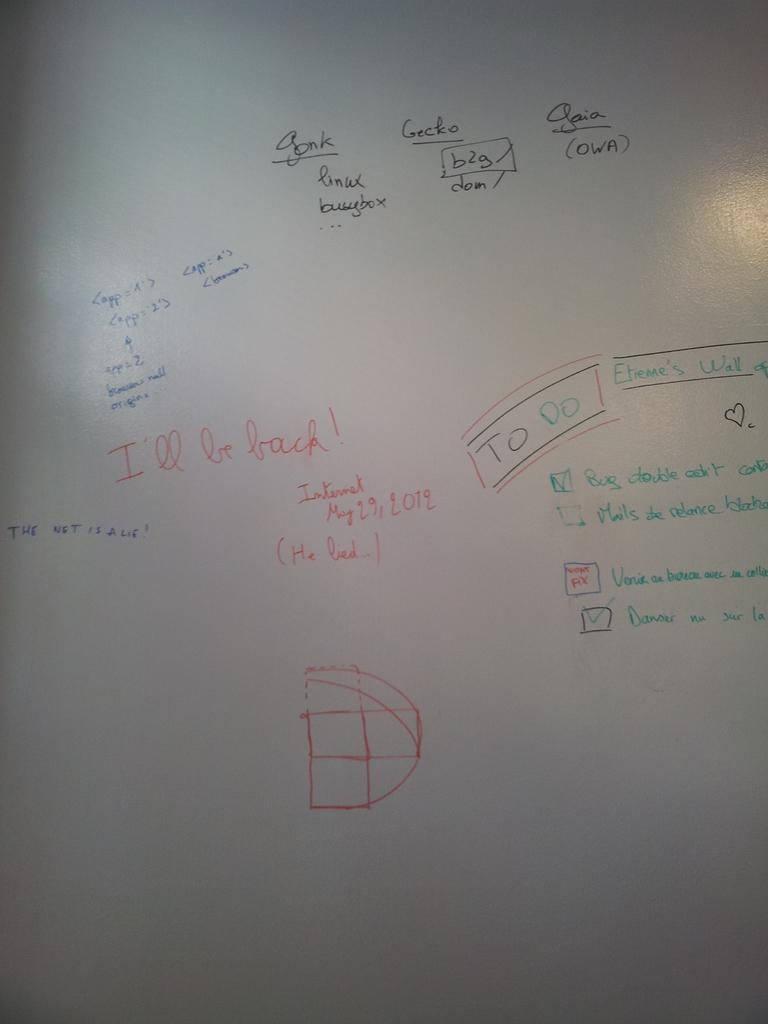<image>
Provide a brief description of the given image. "I'll be back!" is written on a white board. 